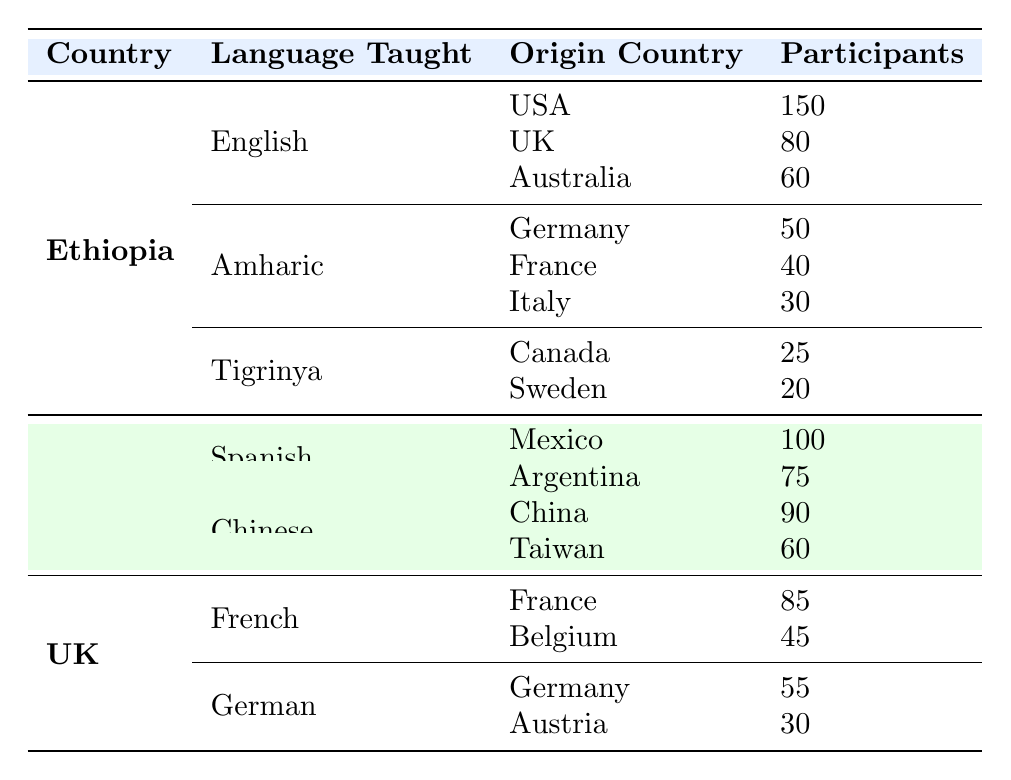How many participants from the USA are involved in English language teaching in Ethiopia? The table shows that the participants from the USA for English language teaching in Ethiopia are 150.
Answer: 150 What is the total number of participants from Germany in Amharic language teaching programs in Ethiopia? The table indicates that there are 50 participants from Germany for Amharic language teaching.
Answer: 50 Is there any participant from Italy in the English language programs? Looking at the table, Italy does not appear under the English language programs, only under Amharic, which has 30 participants. Thus, there are no participants from Italy in English.
Answer: No Which language has the highest number of participants from their origin countries in Ethiopia? For English, the USA has 150, UK has 80, and Australia has 60. For Amharic, Germany has 50, France has 40, and Italy has 30. For Tigrinya, Canada has 25 and Sweden has 20. Comparing these, English has the highest number of 150 participants.
Answer: English What is the combined total of participants from Canada and Sweden for Tigrinya language teaching in Ethiopia? The table shows 25 participants from Canada and 20 from Sweden. Summing these gives 25 + 20 = 45 participants in total for Tigrinya language teaching.
Answer: 45 In the USA's cultural exchange programs, which language has more participants, Spanish or Chinese? For Spanish, the table shows Mexico has 100 and Argentina has 75, totaling 175 participants. For Chinese, China has 90 and Taiwan has 60, totaling 150 participants. Since 175 is greater than 150, Spanish has more participants.
Answer: Spanish How many countries have participants in French language teaching in the UK? The table lists two countries under French language teaching in the UK: France (85 participants) and Belgium (45 participants), thus there are 2 countries in total.
Answer: 2 What is the average number of participants for the German language programs in the UK? The German language program in the UK has participants from Germany (55) and Austria (30). To find the average, sum these values (55 + 30 = 85) and divide by the number of data points (2). Thus, 85 / 2 = 42.5.
Answer: 42.5 